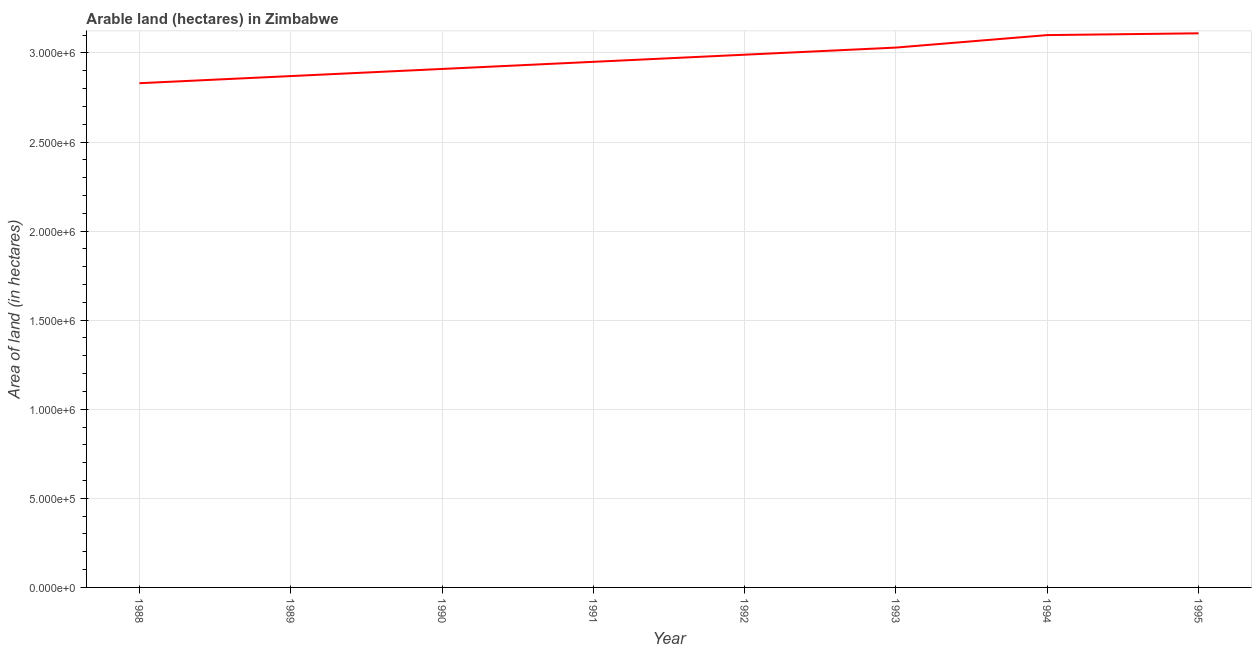What is the area of land in 1989?
Offer a very short reply. 2.87e+06. Across all years, what is the maximum area of land?
Make the answer very short. 3.11e+06. Across all years, what is the minimum area of land?
Provide a short and direct response. 2.83e+06. In which year was the area of land maximum?
Provide a short and direct response. 1995. What is the sum of the area of land?
Your answer should be compact. 2.38e+07. What is the difference between the area of land in 1993 and 1994?
Provide a succinct answer. -7.00e+04. What is the average area of land per year?
Keep it short and to the point. 2.97e+06. What is the median area of land?
Keep it short and to the point. 2.97e+06. In how many years, is the area of land greater than 400000 hectares?
Your response must be concise. 8. Do a majority of the years between 1995 and 1992 (inclusive) have area of land greater than 1600000 hectares?
Provide a succinct answer. Yes. What is the ratio of the area of land in 1990 to that in 1992?
Your answer should be very brief. 0.97. Is the area of land in 1988 less than that in 1989?
Offer a very short reply. Yes. What is the difference between the highest and the second highest area of land?
Keep it short and to the point. 10000. Is the sum of the area of land in 1991 and 1993 greater than the maximum area of land across all years?
Offer a terse response. Yes. What is the difference between the highest and the lowest area of land?
Offer a very short reply. 2.80e+05. How many years are there in the graph?
Offer a terse response. 8. What is the difference between two consecutive major ticks on the Y-axis?
Your answer should be very brief. 5.00e+05. Are the values on the major ticks of Y-axis written in scientific E-notation?
Make the answer very short. Yes. Does the graph contain any zero values?
Offer a terse response. No. Does the graph contain grids?
Your answer should be very brief. Yes. What is the title of the graph?
Ensure brevity in your answer.  Arable land (hectares) in Zimbabwe. What is the label or title of the X-axis?
Make the answer very short. Year. What is the label or title of the Y-axis?
Provide a succinct answer. Area of land (in hectares). What is the Area of land (in hectares) in 1988?
Your answer should be compact. 2.83e+06. What is the Area of land (in hectares) of 1989?
Offer a very short reply. 2.87e+06. What is the Area of land (in hectares) in 1990?
Provide a succinct answer. 2.91e+06. What is the Area of land (in hectares) of 1991?
Your answer should be very brief. 2.95e+06. What is the Area of land (in hectares) in 1992?
Provide a succinct answer. 2.99e+06. What is the Area of land (in hectares) in 1993?
Provide a succinct answer. 3.03e+06. What is the Area of land (in hectares) in 1994?
Ensure brevity in your answer.  3.10e+06. What is the Area of land (in hectares) in 1995?
Give a very brief answer. 3.11e+06. What is the difference between the Area of land (in hectares) in 1988 and 1989?
Ensure brevity in your answer.  -4.00e+04. What is the difference between the Area of land (in hectares) in 1988 and 1990?
Offer a terse response. -8.00e+04. What is the difference between the Area of land (in hectares) in 1988 and 1991?
Your answer should be compact. -1.20e+05. What is the difference between the Area of land (in hectares) in 1988 and 1992?
Provide a short and direct response. -1.60e+05. What is the difference between the Area of land (in hectares) in 1988 and 1993?
Your response must be concise. -2.00e+05. What is the difference between the Area of land (in hectares) in 1988 and 1994?
Offer a very short reply. -2.70e+05. What is the difference between the Area of land (in hectares) in 1988 and 1995?
Your response must be concise. -2.80e+05. What is the difference between the Area of land (in hectares) in 1989 and 1993?
Offer a very short reply. -1.60e+05. What is the difference between the Area of land (in hectares) in 1989 and 1995?
Offer a very short reply. -2.40e+05. What is the difference between the Area of land (in hectares) in 1990 and 1991?
Offer a terse response. -4.00e+04. What is the difference between the Area of land (in hectares) in 1990 and 1993?
Your answer should be compact. -1.20e+05. What is the difference between the Area of land (in hectares) in 1990 and 1994?
Make the answer very short. -1.90e+05. What is the difference between the Area of land (in hectares) in 1990 and 1995?
Offer a very short reply. -2.00e+05. What is the difference between the Area of land (in hectares) in 1991 and 1993?
Ensure brevity in your answer.  -8.00e+04. What is the difference between the Area of land (in hectares) in 1992 and 1993?
Offer a very short reply. -4.00e+04. What is the difference between the Area of land (in hectares) in 1992 and 1994?
Your answer should be very brief. -1.10e+05. What is the difference between the Area of land (in hectares) in 1993 and 1994?
Your answer should be compact. -7.00e+04. What is the difference between the Area of land (in hectares) in 1994 and 1995?
Provide a succinct answer. -10000. What is the ratio of the Area of land (in hectares) in 1988 to that in 1989?
Provide a short and direct response. 0.99. What is the ratio of the Area of land (in hectares) in 1988 to that in 1990?
Provide a succinct answer. 0.97. What is the ratio of the Area of land (in hectares) in 1988 to that in 1992?
Give a very brief answer. 0.95. What is the ratio of the Area of land (in hectares) in 1988 to that in 1993?
Provide a short and direct response. 0.93. What is the ratio of the Area of land (in hectares) in 1988 to that in 1995?
Offer a very short reply. 0.91. What is the ratio of the Area of land (in hectares) in 1989 to that in 1990?
Your answer should be compact. 0.99. What is the ratio of the Area of land (in hectares) in 1989 to that in 1992?
Provide a short and direct response. 0.96. What is the ratio of the Area of land (in hectares) in 1989 to that in 1993?
Your answer should be very brief. 0.95. What is the ratio of the Area of land (in hectares) in 1989 to that in 1994?
Provide a succinct answer. 0.93. What is the ratio of the Area of land (in hectares) in 1989 to that in 1995?
Provide a short and direct response. 0.92. What is the ratio of the Area of land (in hectares) in 1990 to that in 1992?
Your response must be concise. 0.97. What is the ratio of the Area of land (in hectares) in 1990 to that in 1994?
Provide a short and direct response. 0.94. What is the ratio of the Area of land (in hectares) in 1990 to that in 1995?
Your answer should be very brief. 0.94. What is the ratio of the Area of land (in hectares) in 1991 to that in 1995?
Offer a terse response. 0.95. What is the ratio of the Area of land (in hectares) in 1992 to that in 1994?
Offer a very short reply. 0.96. What is the ratio of the Area of land (in hectares) in 1992 to that in 1995?
Your answer should be very brief. 0.96. What is the ratio of the Area of land (in hectares) in 1993 to that in 1995?
Your answer should be compact. 0.97. What is the ratio of the Area of land (in hectares) in 1994 to that in 1995?
Give a very brief answer. 1. 